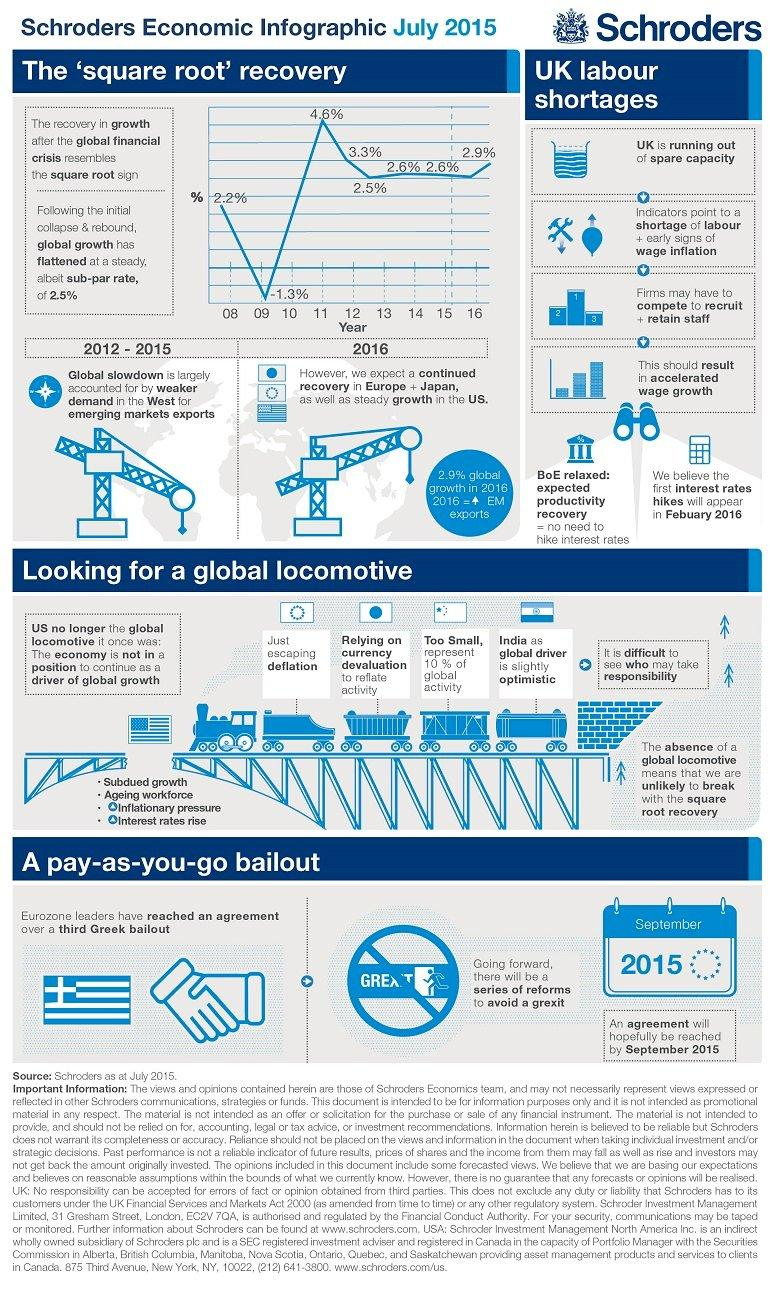Outline some significant characteristics in this image. The graph showing the recovery rate after the economic recession resembles the symbol of the square root. The country of Japan is known for reducing the value of its currency in order to stimulate its economy. At the beginning of 2011, the percentage of recovery was 4.6%. 